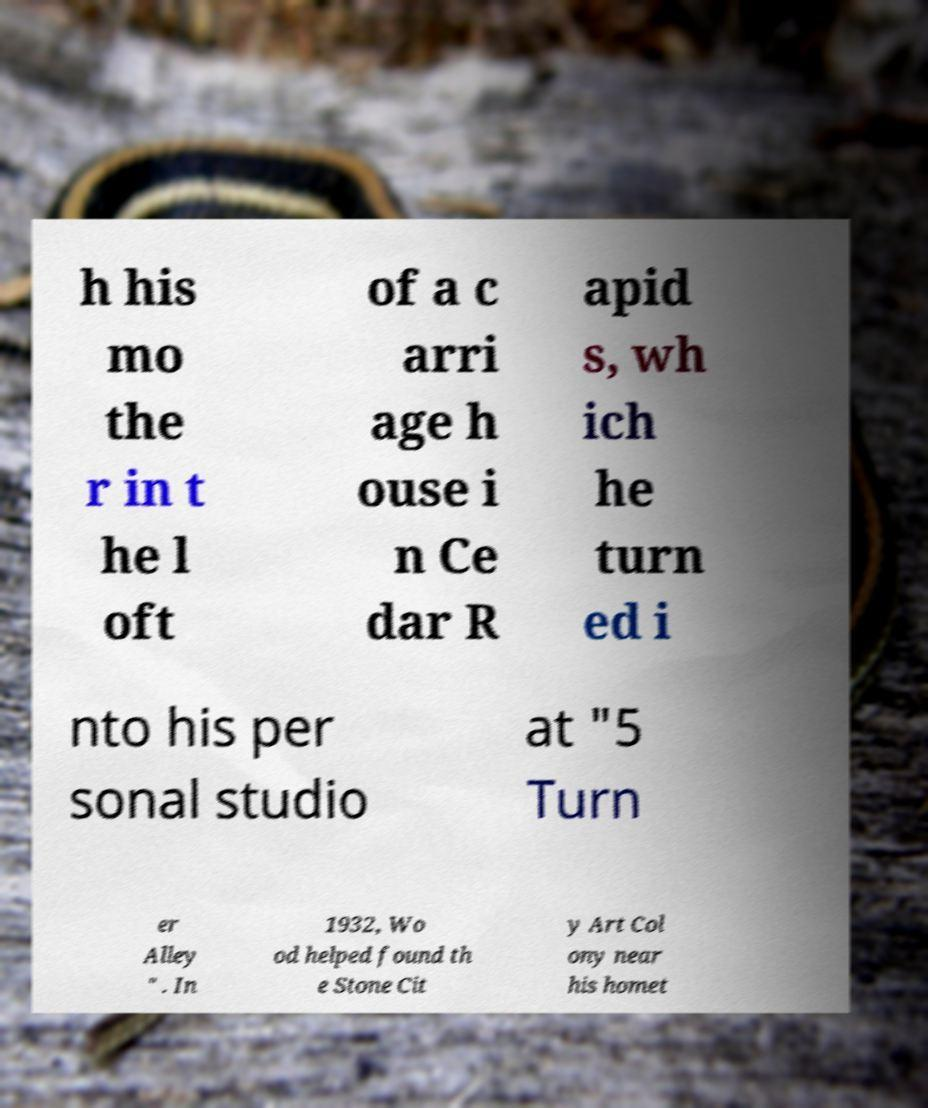Could you assist in decoding the text presented in this image and type it out clearly? h his mo the r in t he l oft of a c arri age h ouse i n Ce dar R apid s, wh ich he turn ed i nto his per sonal studio at "5 Turn er Alley " . In 1932, Wo od helped found th e Stone Cit y Art Col ony near his homet 